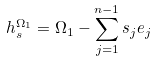Convert formula to latex. <formula><loc_0><loc_0><loc_500><loc_500>h _ { s } ^ { \Omega _ { 1 } } = \Omega _ { 1 } - \sum _ { j = 1 } ^ { n - 1 } s _ { j } e _ { j }</formula> 